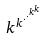Convert formula to latex. <formula><loc_0><loc_0><loc_500><loc_500>k ^ { k ^ { \cdot ^ { \cdot ^ { k ^ { k } } } } }</formula> 